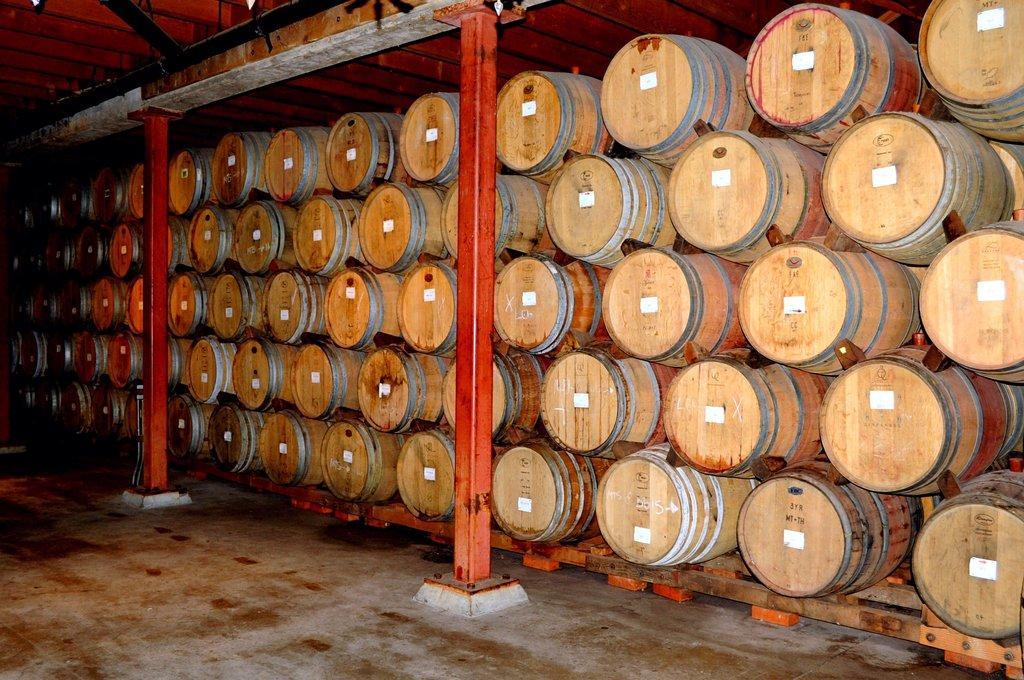Describe this image in one or two sentences. In this picture we can see the floor, pillars and a group of barrels and in the background we can see the wall and rods. 